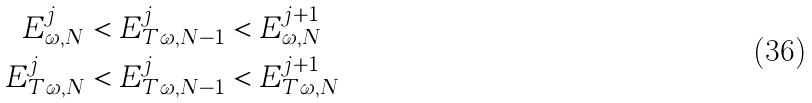<formula> <loc_0><loc_0><loc_500><loc_500>E _ { \omega , N } ^ { j } < E _ { T \omega , N - 1 } ^ { j } & < E _ { \omega , N } ^ { j + 1 } \\ E _ { T \omega , N } ^ { j } < E _ { T \omega , N - 1 } ^ { j } & < E _ { T \omega , N } ^ { j + 1 }</formula> 